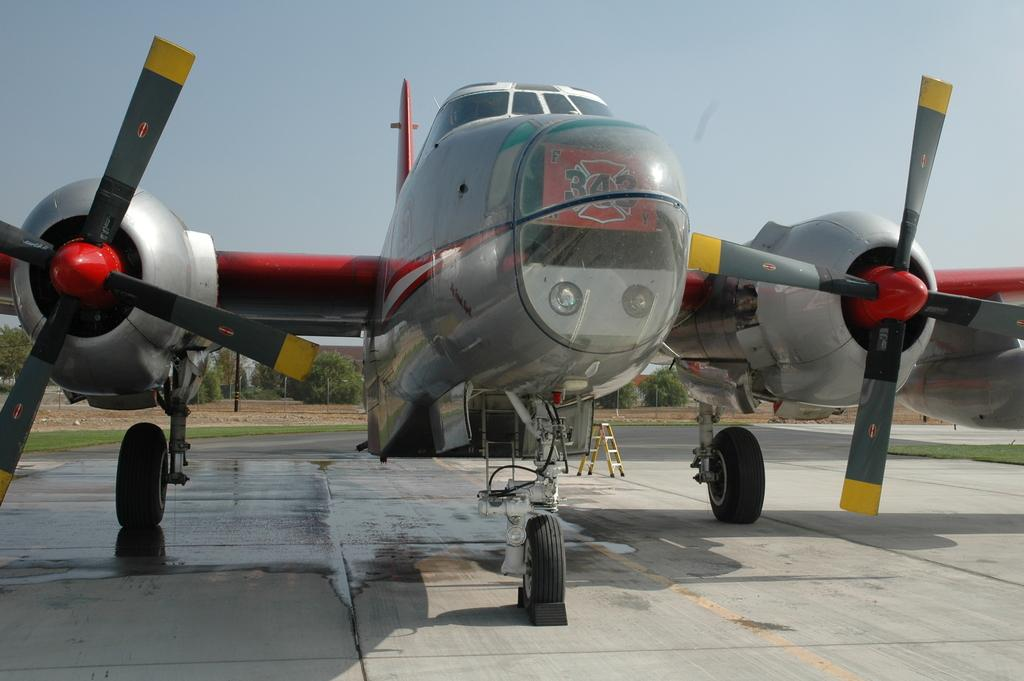What is the main subject in the front of the image? There is an aircraft in the front of the image. What can be seen in the background of the image? There are trees and grass in the background of the image. What is visible at the top of the image? The sky is visible at the top of the image. What type of rake is being used to maintain the grass in the image? There is no rake present in the image; it only features an aircraft, trees, grass, and the sky. 